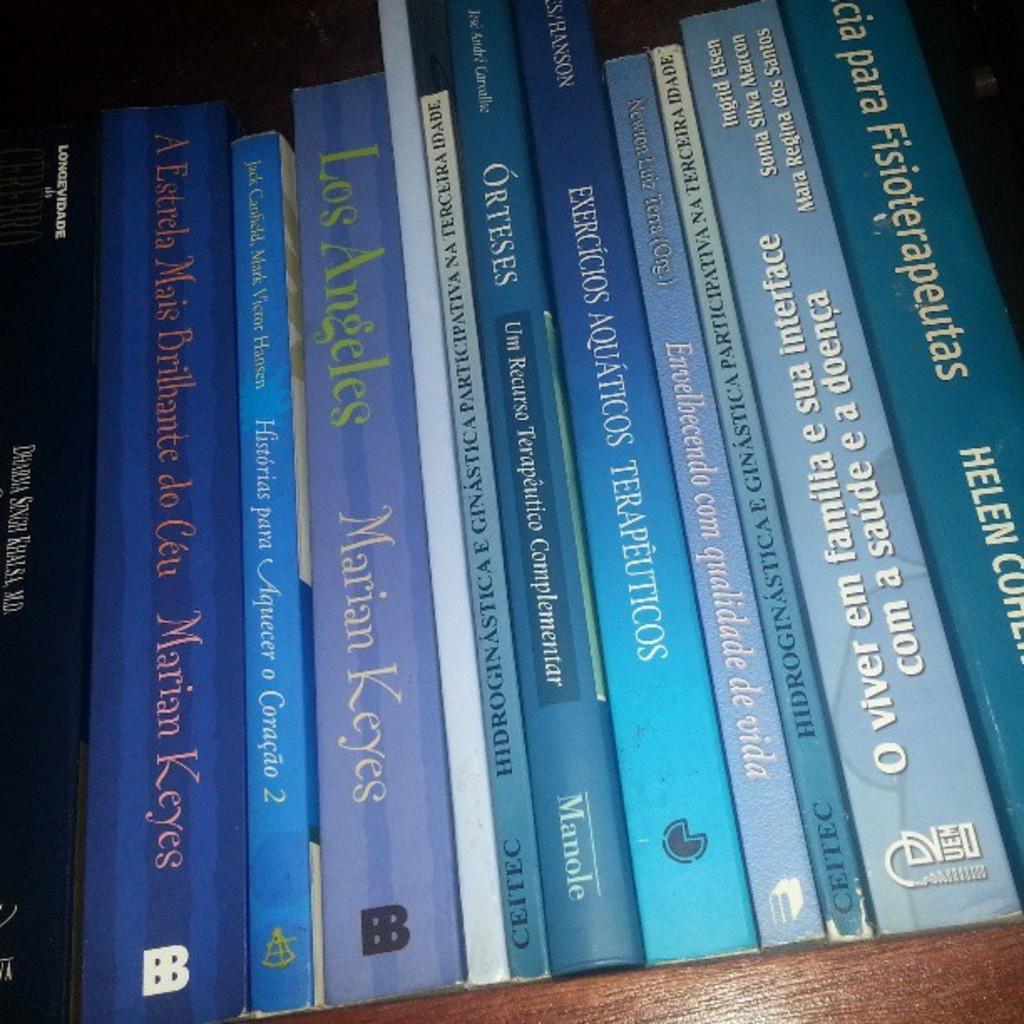Who is the author of the book "los angeles"?
Your answer should be compact. Marian keyes. What is the first name of the author of the book to the far right?
Offer a terse response. Helen. 